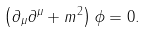Convert formula to latex. <formula><loc_0><loc_0><loc_500><loc_500>\left ( \partial _ { \mu } \partial ^ { \mu } + m ^ { 2 } \right ) \phi = 0 .</formula> 